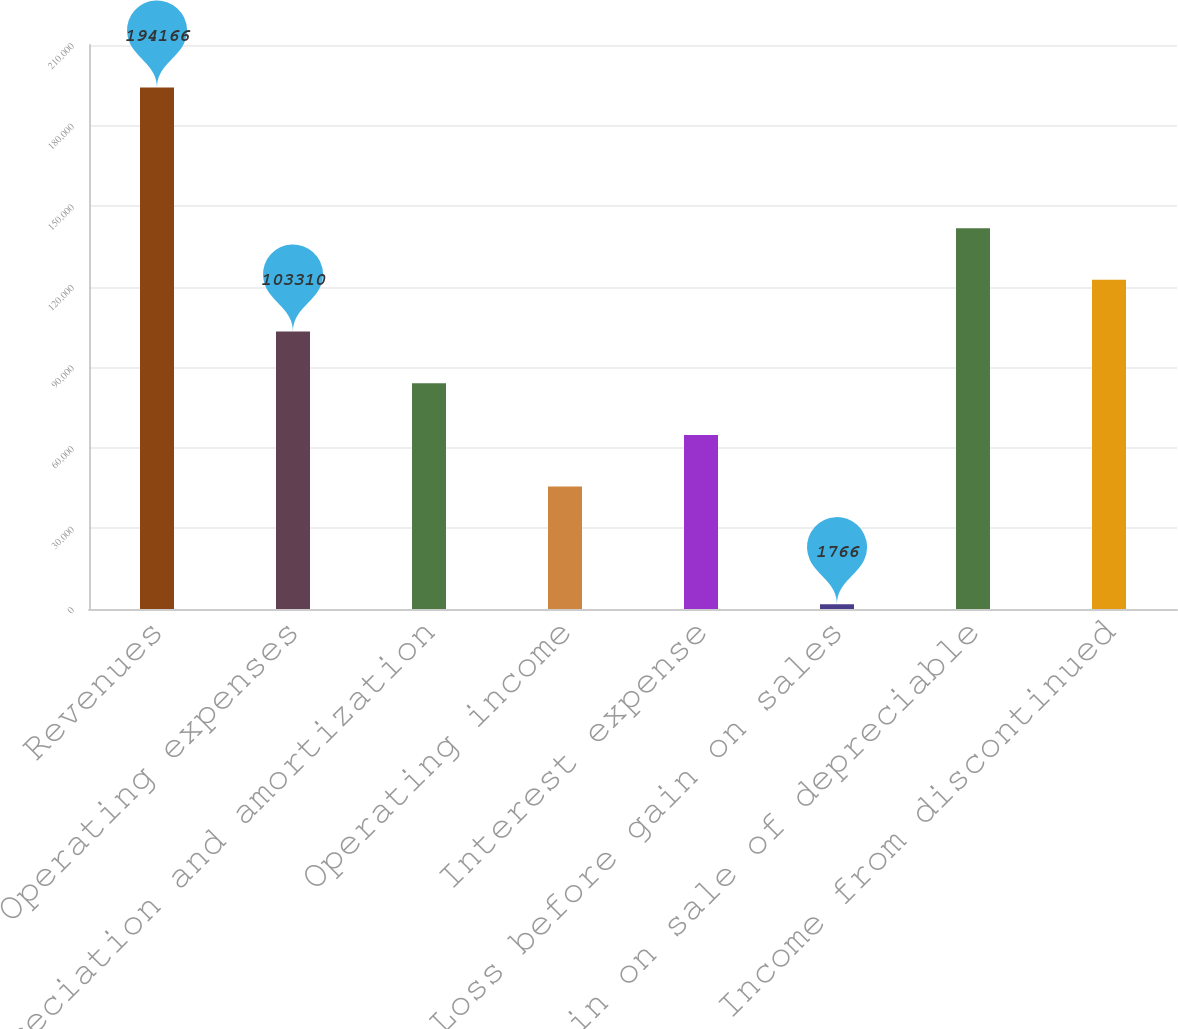<chart> <loc_0><loc_0><loc_500><loc_500><bar_chart><fcel>Revenues<fcel>Operating expenses<fcel>Depreciation and amortization<fcel>Operating income<fcel>Interest expense<fcel>Loss before gain on sales<fcel>Gain on sale of depreciable<fcel>Income from discontinued<nl><fcel>194166<fcel>103310<fcel>84070<fcel>45590<fcel>64830<fcel>1766<fcel>141790<fcel>122550<nl></chart> 